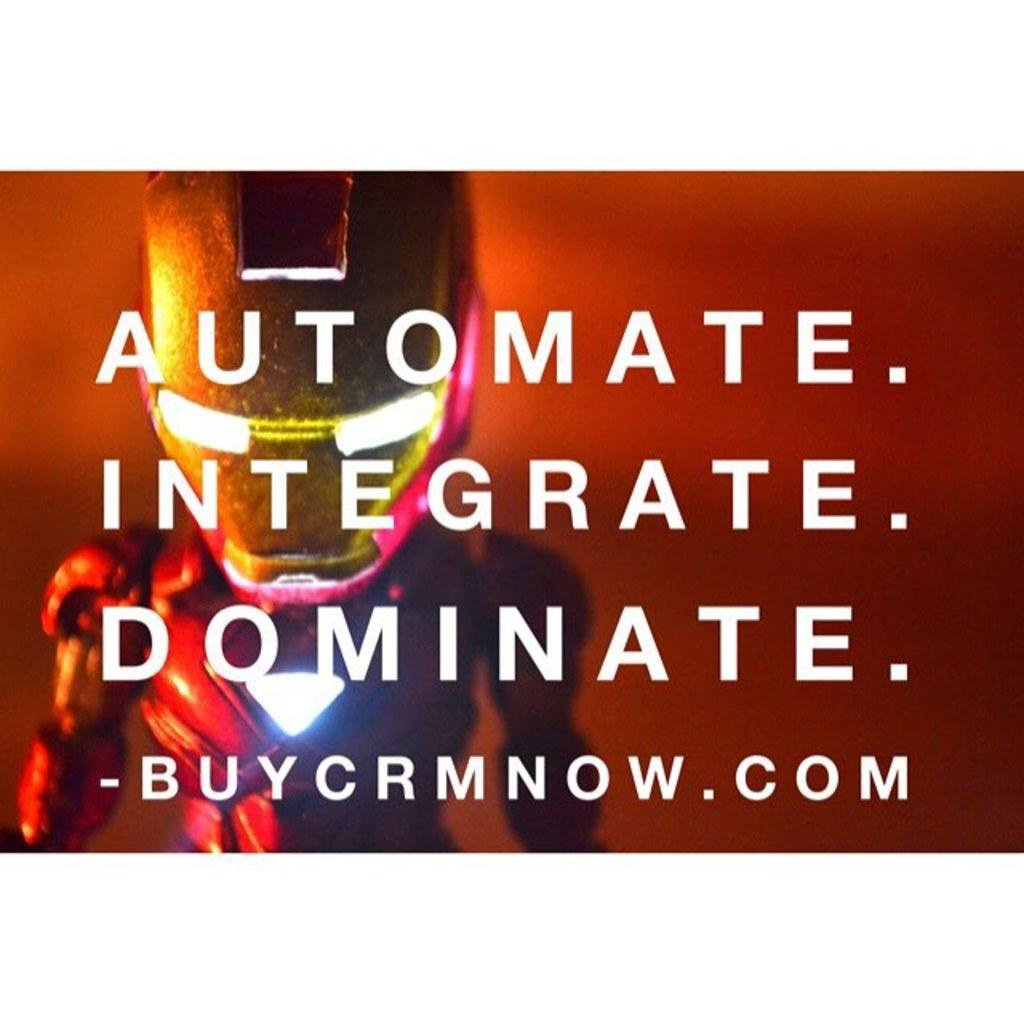<image>
Describe the image concisely. Ad that says to Automate, Integrate, and Dominate. 